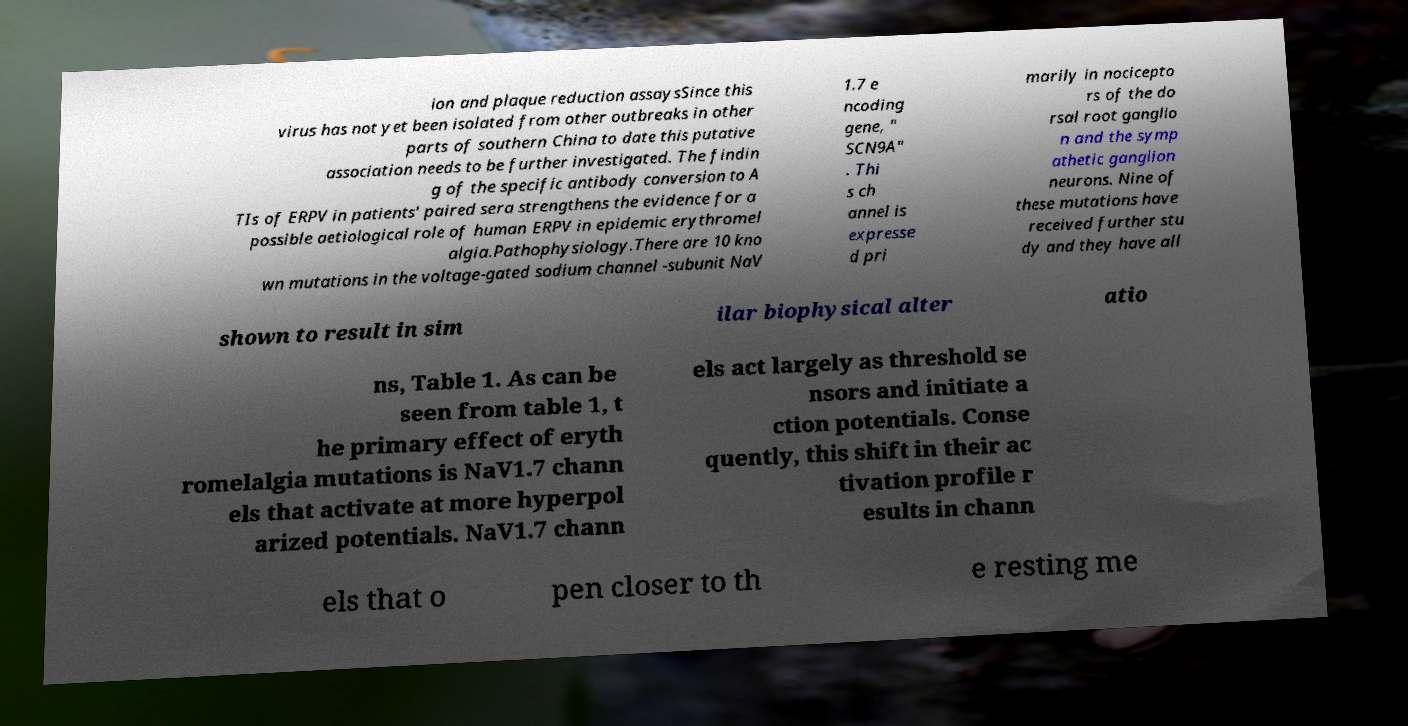What messages or text are displayed in this image? I need them in a readable, typed format. ion and plaque reduction assaysSince this virus has not yet been isolated from other outbreaks in other parts of southern China to date this putative association needs to be further investigated. The findin g of the specific antibody conversion to A TIs of ERPV in patients' paired sera strengthens the evidence for a possible aetiological role of human ERPV in epidemic erythromel algia.Pathophysiology.There are 10 kno wn mutations in the voltage-gated sodium channel -subunit NaV 1.7 e ncoding gene, " SCN9A" . Thi s ch annel is expresse d pri marily in nocicepto rs of the do rsal root ganglio n and the symp athetic ganglion neurons. Nine of these mutations have received further stu dy and they have all shown to result in sim ilar biophysical alter atio ns, Table 1. As can be seen from table 1, t he primary effect of eryth romelalgia mutations is NaV1.7 chann els that activate at more hyperpol arized potentials. NaV1.7 chann els act largely as threshold se nsors and initiate a ction potentials. Conse quently, this shift in their ac tivation profile r esults in chann els that o pen closer to th e resting me 